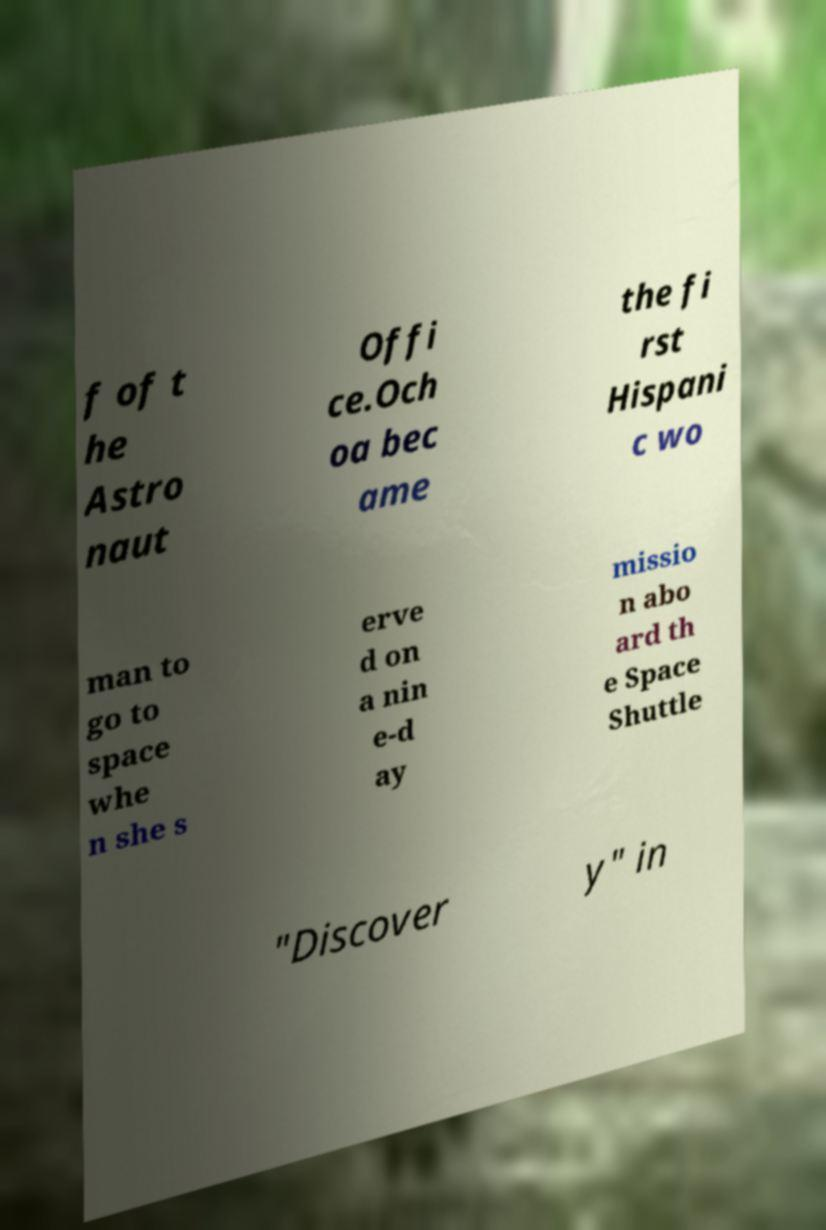Can you accurately transcribe the text from the provided image for me? f of t he Astro naut Offi ce.Och oa bec ame the fi rst Hispani c wo man to go to space whe n she s erve d on a nin e-d ay missio n abo ard th e Space Shuttle "Discover y" in 